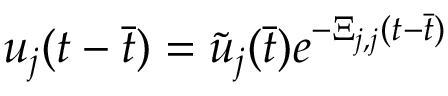<formula> <loc_0><loc_0><loc_500><loc_500>u _ { j } ( t - \ B a r { t } ) = \tilde { u } _ { j } ( \ B a r { t } ) e ^ { - \Xi _ { j , j } ( t - \ B a r { t } ) }</formula> 